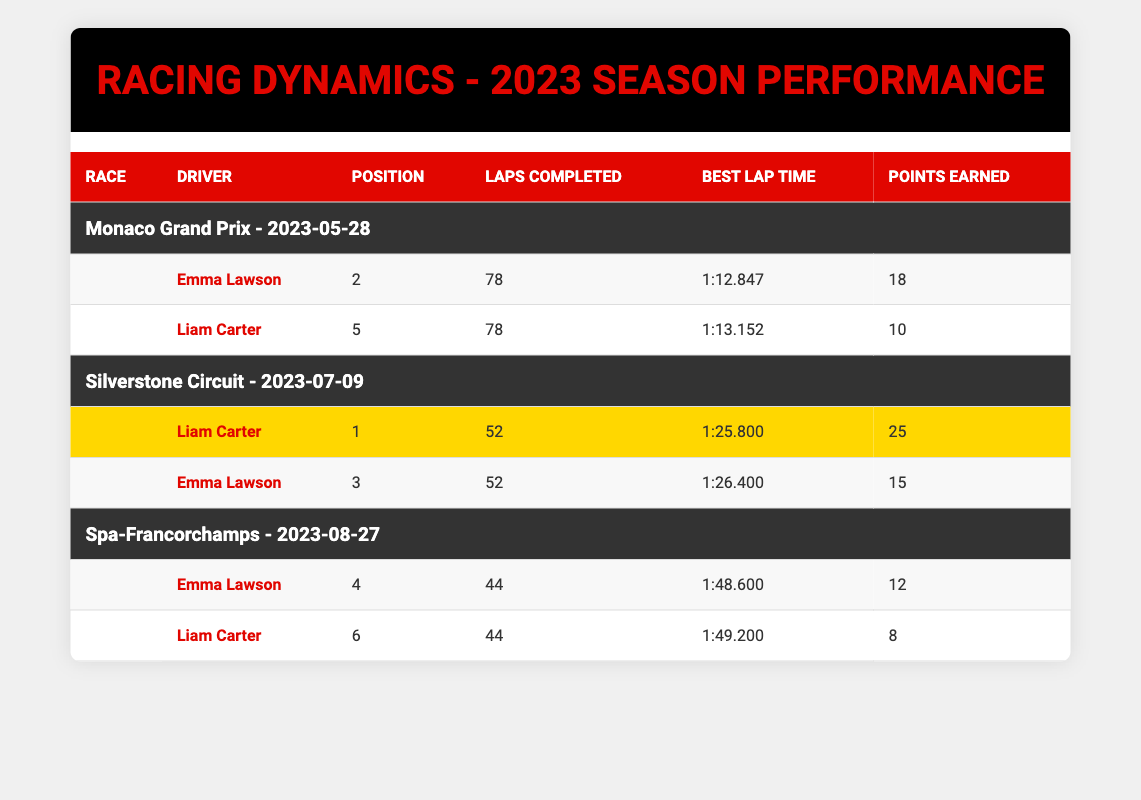What position did Emma Lawson finish in the Silverstone Circuit race? In the Silverstone Circuit race, Emma Lawson's position is listed in the table as 3.
Answer: 3 How many points did Liam Carter earn in the Monaco Grand Prix? Liam Carter earned 10 points in the Monaco Grand Prix, as indicated in the points earned column.
Answer: 10 Which driver had the fastest lap time during the Monaco Grand Prix? The best lap time for Emma Lawson in the Monaco Grand Prix is 1:12.847, and for Liam Carter, it is 1:13.152. Emma Lawson had the fastest lap time.
Answer: Emma Lawson What is the difference in points earned by the two drivers in the Silverstone Circuit race? Liam Carter earned 25 points and Emma Lawson earned 15 points in the Silverstone Circuit race. The difference is 25 - 15 = 10 points.
Answer: 10 Did Emma Lawson complete more laps than Liam Carter in the Spa-Francorchamps race? Emma Lawson completed 44 laps while Liam Carter also completed 44 laps. Therefore, the statement that Emma Lawson completed more laps is false.
Answer: No What is the average position of Emma Lawson across all three races? Emma Lawson's positions in each race are 2, 3, and 4. To find the average, sum the positions: (2 + 3 + 4) = 9, then divide by the number of races (3), giving 9 / 3 = 3.
Answer: 3 Which race had the highest points earned by a driver from Racing Dynamics? In the Silverstone Circuit race, Liam Carter earned the most points, which is 25 points. This is higher than the points earned in the other two races.
Answer: Silverstone Circuit How many total laps did the two drivers complete in the three races combined? In the Monaco Grand Prix, both drivers completed 78 laps; in Silverstone, both completed 52 laps; and in Spa-Francorchamps, both completed 44 laps. Summing these gives a total of (78 + 78 + 52 + 52 + 44 + 44) = 348 laps.
Answer: 348 Did either driver achieve a podium finish in every race they participated in? Emma Lawson finished 2nd and 3rd in two races, and rounded out with 4th, while Liam Carter had a 1st place finish, a 5th, and a 6th, indicating neither driver achieved a podium finish (top 3) in every race.
Answer: No 